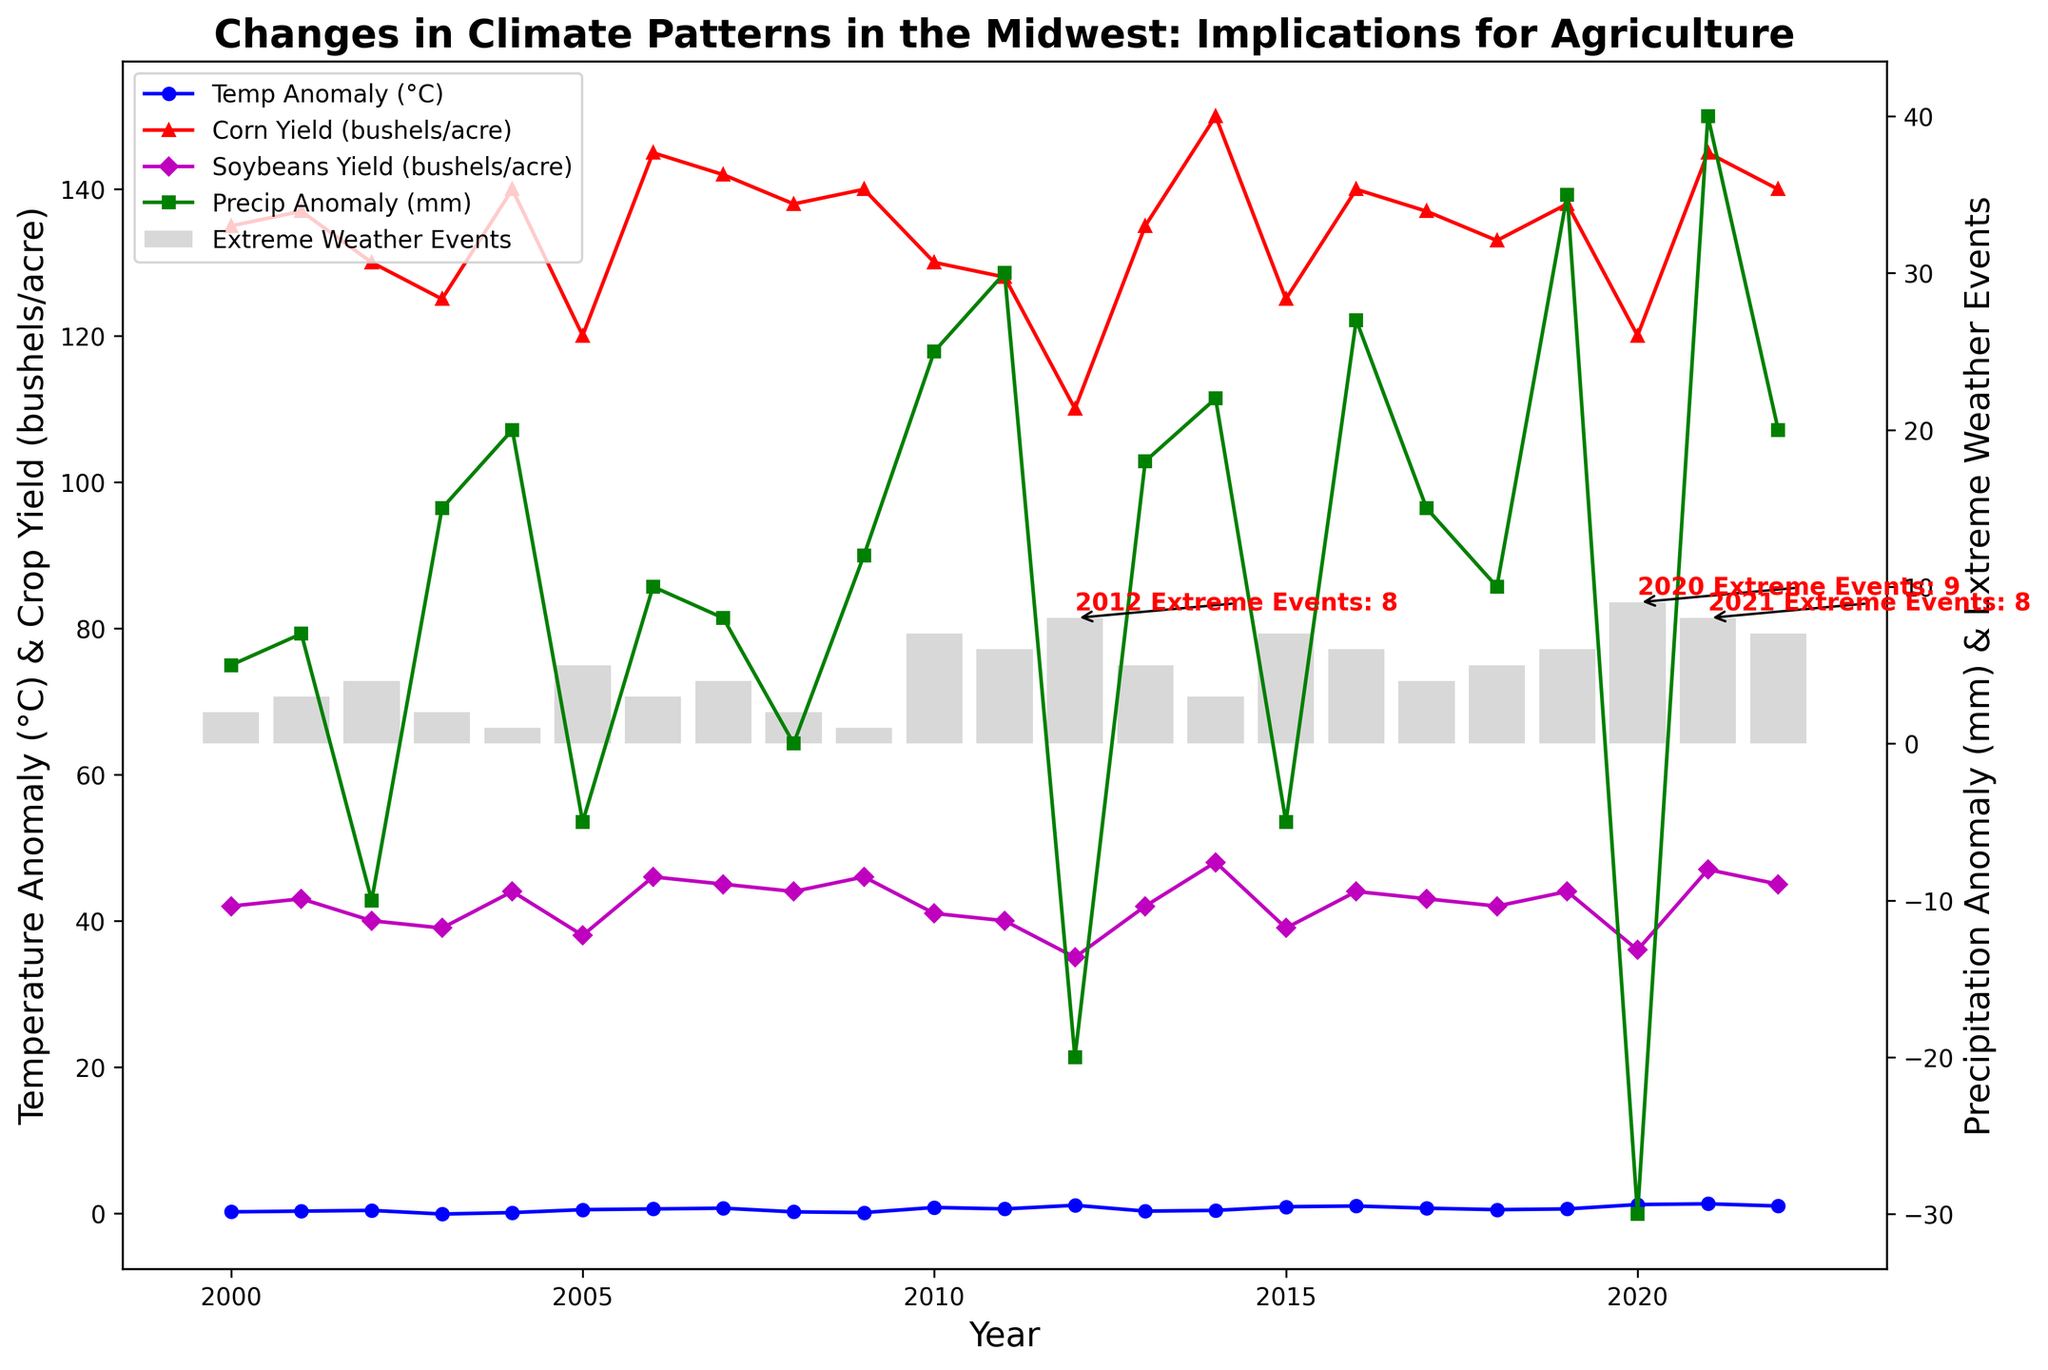What year had the highest number of extreme weather events? The figure annotates the year 2020 with the highest number of extreme weather events, indicated by the bar height and the annotation.
Answer: 2020 Compare the corn yield (bushels/acre) in 2012 and 2021. Which year was higher? In 2012, the corn yield is lower compared to 2021. The figure shows 110 bushels/acre in 2012 and 145 bushels/acre in 2021.
Answer: 2021 What's the relationship between temperature anomaly and extreme weather events for the year 2020? In 2020, there is the highest temperature anomaly (1.2°C) and the highest count of extreme weather events (9), suggesting a possible relationship between higher temperature anomalies and increased extreme weather events.
Answer: High temperature anomaly correlates with high extreme weather events What is the average corn yield (bushels/acre) for the years with the highest and lowest temperature anomalies? The highest temperature anomaly occurs in 2021 with a corn yield of 145 bushels/acre, and the lowest anomaly in 2003 with a corn yield of 125 bushels/acre. The average is (145 + 125) / 2 = 135 bushels/acre.
Answer: 135 bushels/acre How does the precipitation anomaly in 2020 compare visually to other years? The precipitation anomaly in 2020 is -30 mm, one of the lowest in the entire dataset, visible as one of the lowest points on the green line.
Answer: 2020 has a significantly lower precipitation anomaly Identify the years where both corn and soybean yields were above their respective overall averages. Corn yield overall average (sum of yields/number of years) is 133. Instances above are 2006, 2007, 2009, 2014, 2016, 2021. Soybean yield overall average is 42. Instances above are 2004, 2006, 2007, 2009, 2014, 2016, 2017, 2019, 2021. Common years are 2006, 2007, 2009, 2014, 2016, 2021.
Answer: 2006, 2007, 2009, 2014, 2016, 2021 What is the trend of extreme weather events from 2000 to 2022? The plot shows an increasing trend in extreme weather events, with annotations highlighting notable high values in later years, especially 2020.
Answer: Increasing 